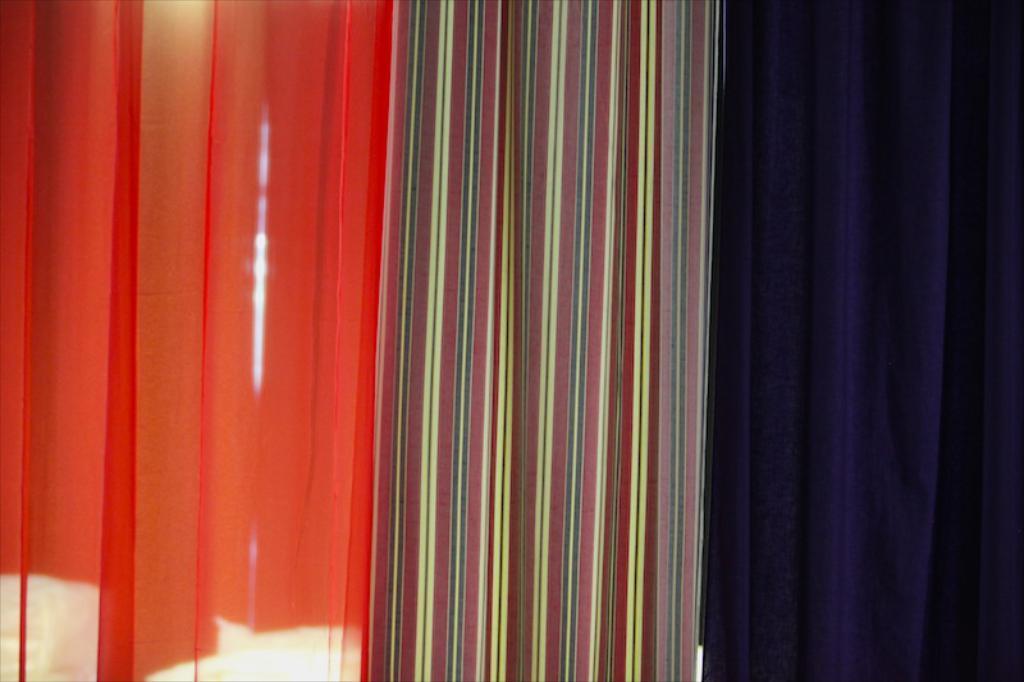Describe this image in one or two sentences. In this picture I can see three colorful clothes. 